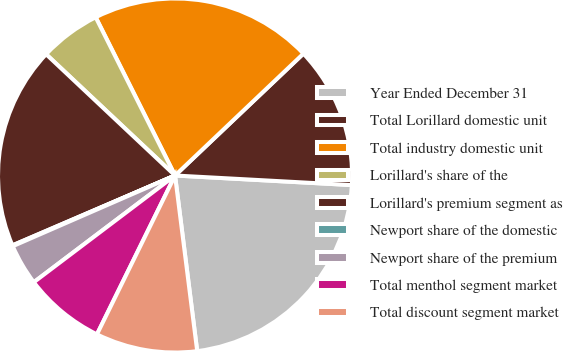Convert chart to OTSL. <chart><loc_0><loc_0><loc_500><loc_500><pie_chart><fcel>Year Ended December 31<fcel>Total Lorillard domestic unit<fcel>Total industry domestic unit<fcel>Lorillard's share of the<fcel>Lorillard's premium segment as<fcel>Newport share of the domestic<fcel>Newport share of the premium<fcel>Total menthol segment market<fcel>Total discount segment market<nl><fcel>22.14%<fcel>12.95%<fcel>20.31%<fcel>5.59%<fcel>18.47%<fcel>0.08%<fcel>3.76%<fcel>7.43%<fcel>9.27%<nl></chart> 